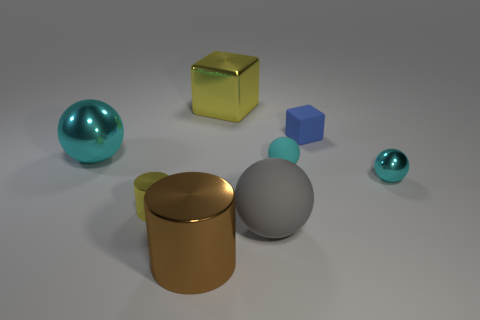The metallic block that is the same color as the tiny shiny cylinder is what size?
Give a very brief answer. Large. There is a metallic sphere that is on the left side of the blue rubber block; how big is it?
Make the answer very short. Large. Is there a cylinder that has the same color as the big shiny block?
Keep it short and to the point. Yes. Do the gray rubber sphere and the shiny ball that is to the right of the big brown cylinder have the same size?
Make the answer very short. No. There is a metallic thing that is the same color as the big block; what shape is it?
Offer a terse response. Cylinder. There is a yellow block; what number of large gray rubber things are in front of it?
Your answer should be compact. 1. What is the material of the object that is both in front of the small cylinder and behind the large brown cylinder?
Ensure brevity in your answer.  Rubber. What number of cylinders are either large matte objects or small metal objects?
Your answer should be very brief. 1. What material is the other thing that is the same shape as the big yellow object?
Your response must be concise. Rubber. What size is the block that is made of the same material as the brown thing?
Give a very brief answer. Large. 